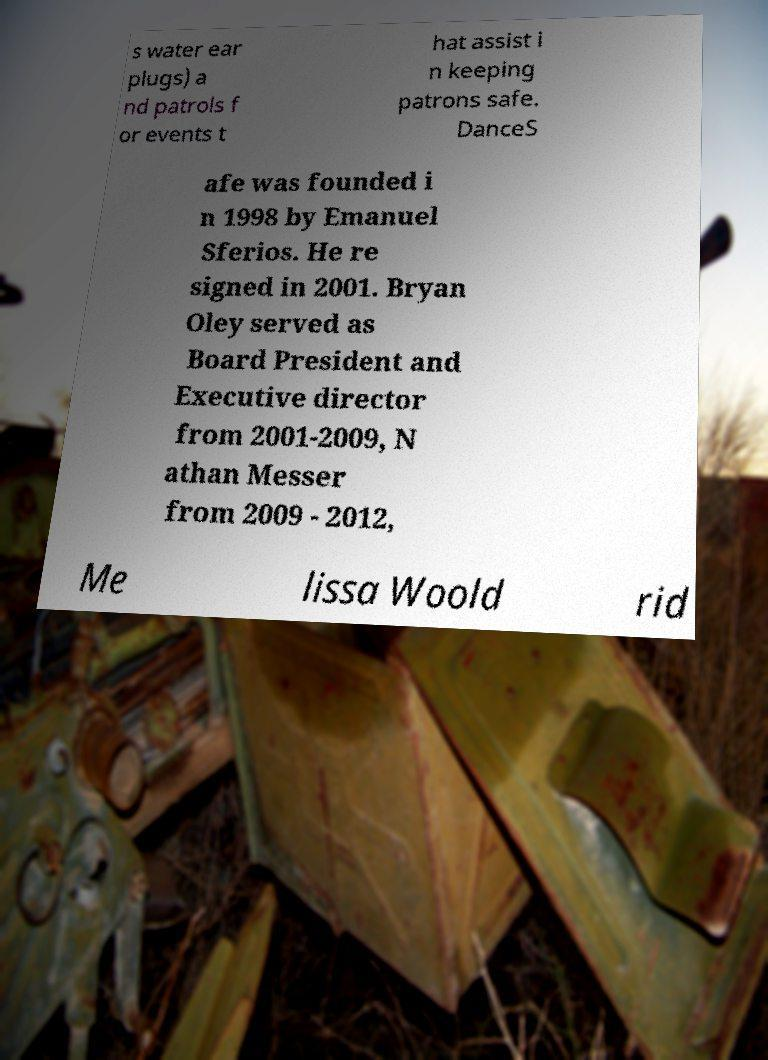Please read and relay the text visible in this image. What does it say? s water ear plugs) a nd patrols f or events t hat assist i n keeping patrons safe. DanceS afe was founded i n 1998 by Emanuel Sferios. He re signed in 2001. Bryan Oley served as Board President and Executive director from 2001-2009, N athan Messer from 2009 - 2012, Me lissa Woold rid 